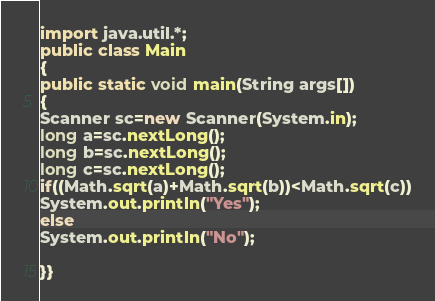<code> <loc_0><loc_0><loc_500><loc_500><_Java_>import java.util.*;
public class Main
{
public static void main(String args[])
{
Scanner sc=new Scanner(System.in);
long a=sc.nextLong();
long b=sc.nextLong();
long c=sc.nextLong();
if((Math.sqrt(a)+Math.sqrt(b))<Math.sqrt(c))
System.out.println("Yes");
else
System.out.println("No");

}}</code> 